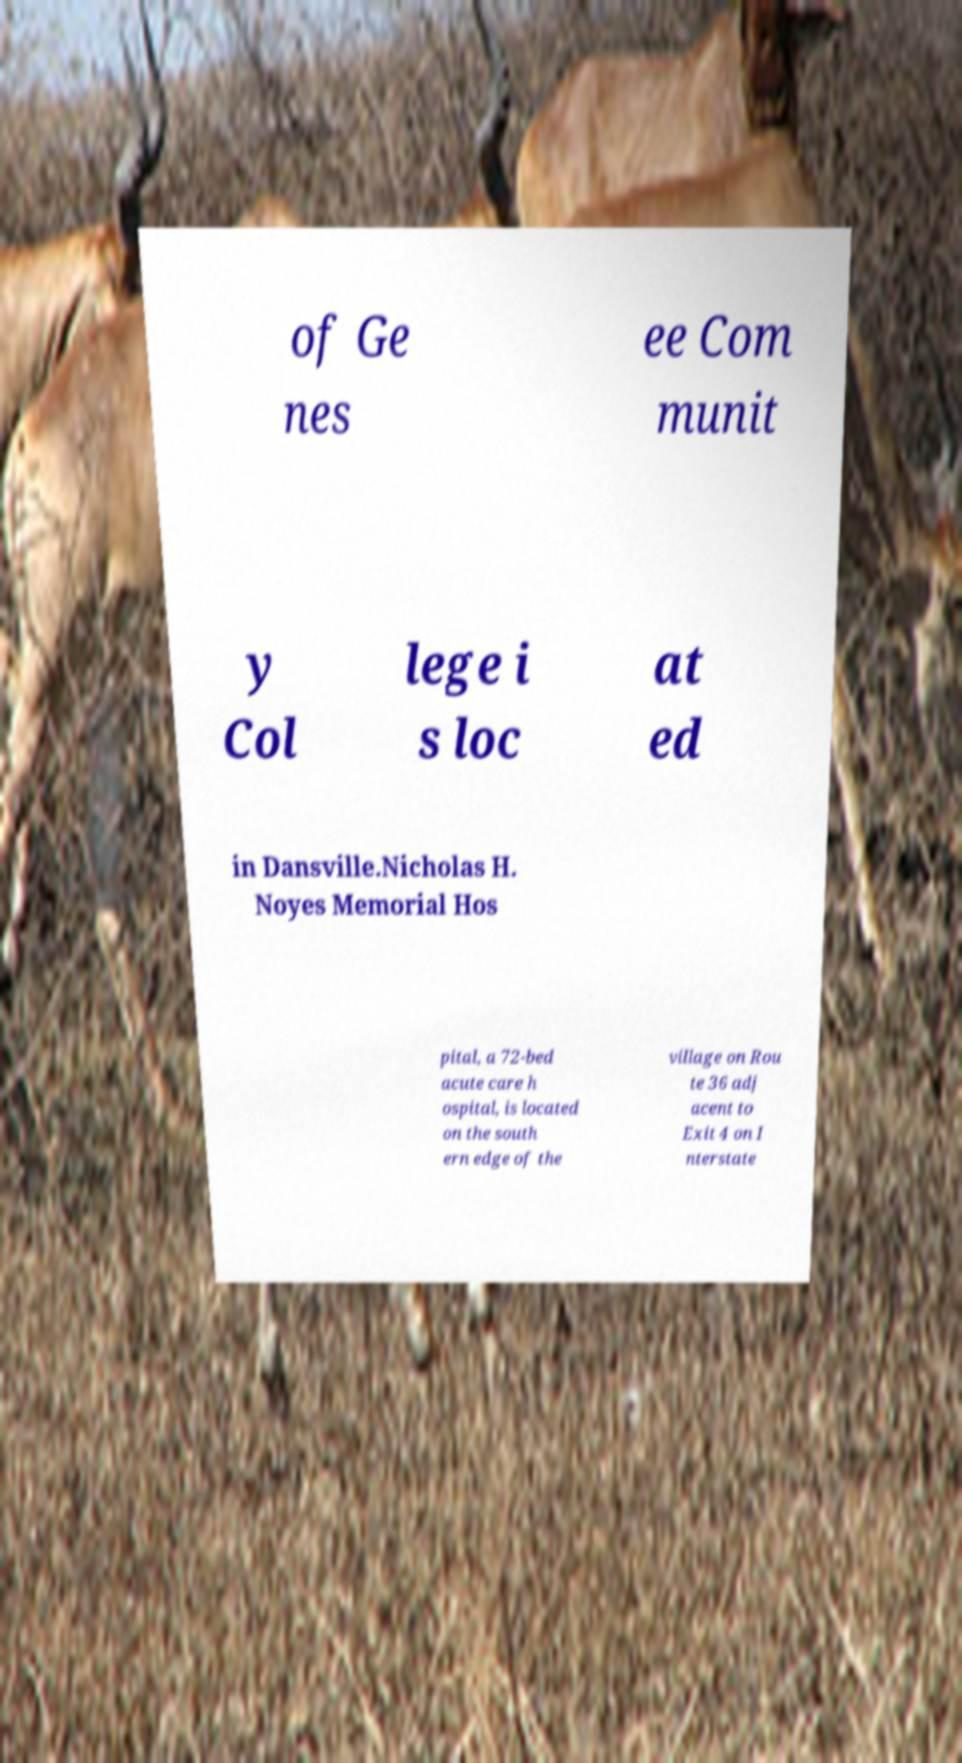Could you extract and type out the text from this image? of Ge nes ee Com munit y Col lege i s loc at ed in Dansville.Nicholas H. Noyes Memorial Hos pital, a 72-bed acute care h ospital, is located on the south ern edge of the village on Rou te 36 adj acent to Exit 4 on I nterstate 